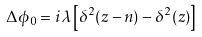Convert formula to latex. <formula><loc_0><loc_0><loc_500><loc_500>\Delta \phi _ { 0 } = i \lambda \left [ \delta ^ { 2 } ( z - n ) - \delta ^ { 2 } ( z ) \right ]</formula> 